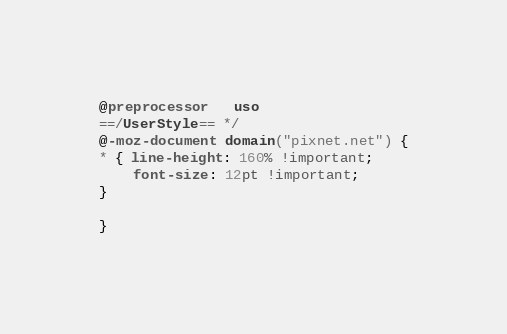Convert code to text. <code><loc_0><loc_0><loc_500><loc_500><_CSS_>@preprocessor   uso
==/UserStyle== */
@-moz-document domain("pixnet.net") {
* { line-height: 160% !important;
    font-size: 12pt !important;
}

}</code> 